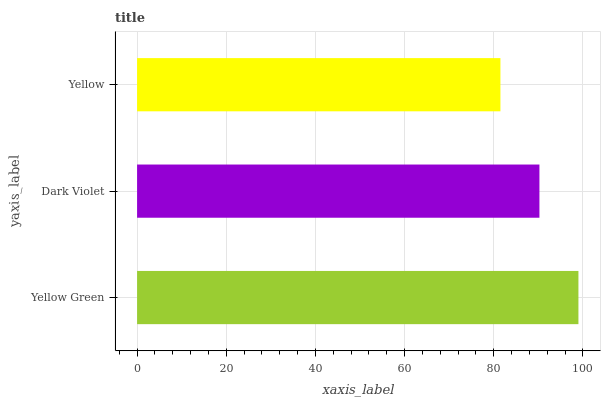Is Yellow the minimum?
Answer yes or no. Yes. Is Yellow Green the maximum?
Answer yes or no. Yes. Is Dark Violet the minimum?
Answer yes or no. No. Is Dark Violet the maximum?
Answer yes or no. No. Is Yellow Green greater than Dark Violet?
Answer yes or no. Yes. Is Dark Violet less than Yellow Green?
Answer yes or no. Yes. Is Dark Violet greater than Yellow Green?
Answer yes or no. No. Is Yellow Green less than Dark Violet?
Answer yes or no. No. Is Dark Violet the high median?
Answer yes or no. Yes. Is Dark Violet the low median?
Answer yes or no. Yes. Is Yellow Green the high median?
Answer yes or no. No. Is Yellow the low median?
Answer yes or no. No. 